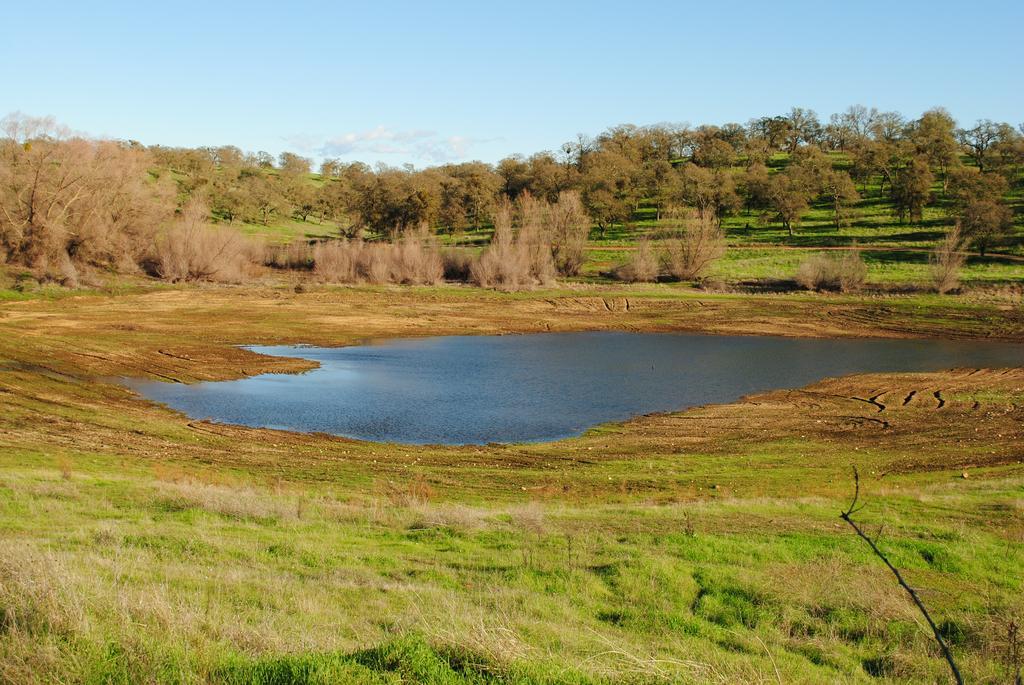In one or two sentences, can you explain what this image depicts? In this image we can see sky with clouds, trees, ground, shrubs, bushes, grass and pond. 